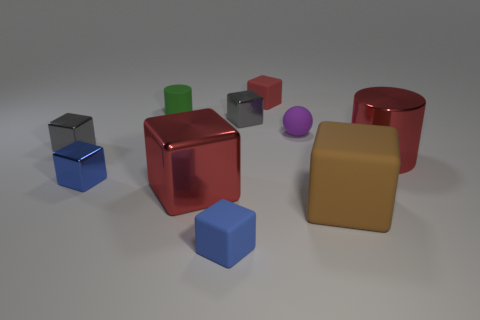There is a red thing that is both left of the purple matte sphere and in front of the small red block; what is it made of?
Make the answer very short. Metal. Is the shape of the brown rubber object the same as the tiny shiny thing in front of the red shiny cylinder?
Your response must be concise. Yes. Is the color of the matte cylinder the same as the rubber block that is behind the purple matte thing?
Provide a short and direct response. No. The red thing that is made of the same material as the ball is what shape?
Make the answer very short. Cube. There is a big red shiny thing in front of the red shiny cylinder; is it the same shape as the small blue metallic object?
Provide a succinct answer. Yes. There is a green object that is left of the tiny rubber cube behind the large brown rubber object; what size is it?
Your response must be concise. Small. What is the color of the ball that is made of the same material as the green cylinder?
Ensure brevity in your answer.  Purple. What number of purple spheres have the same size as the red cylinder?
Provide a short and direct response. 0. What number of blue things are rubber cylinders or tiny metallic cubes?
Provide a succinct answer. 1. What number of objects are either cylinders or blocks that are behind the big cylinder?
Provide a short and direct response. 5. 